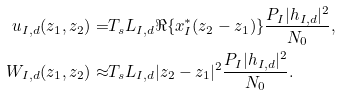Convert formula to latex. <formula><loc_0><loc_0><loc_500><loc_500>u _ { I , d } ( z _ { 1 } , z _ { 2 } ) = & T _ { s } L _ { I , d } \Re \{ x _ { I } ^ { * } ( z _ { 2 } - z _ { 1 } ) \} \frac { P _ { I } | h _ { I , d } | ^ { 2 } } { N _ { 0 } } , \\ W _ { I , d } ( z _ { 1 } , z _ { 2 } ) \approx & T _ { s } L _ { I , d } | z _ { 2 } - z _ { 1 } | ^ { 2 } \frac { P _ { I } | h _ { I , d } | ^ { 2 } } { N _ { 0 } } .</formula> 